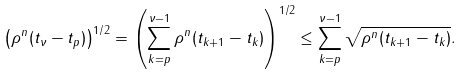Convert formula to latex. <formula><loc_0><loc_0><loc_500><loc_500>\left ( \rho ^ { n } ( t _ { \nu } - t _ { p } ) \right ) ^ { 1 / 2 } = \left ( \sum _ { k = p } ^ { \nu - 1 } \rho ^ { n } ( t _ { k + 1 } - t _ { k } ) \right ) ^ { 1 / 2 } \leq \sum _ { k = p } ^ { \nu - 1 } \sqrt { \rho ^ { n } ( t _ { k + 1 } - t _ { k } ) } .</formula> 